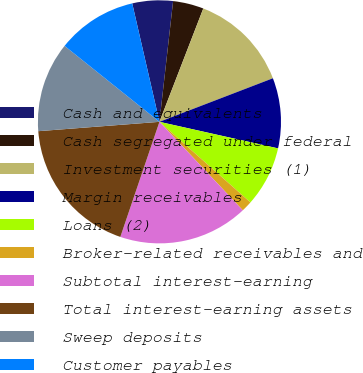Convert chart to OTSL. <chart><loc_0><loc_0><loc_500><loc_500><pie_chart><fcel>Cash and equivalents<fcel>Cash segregated under federal<fcel>Investment securities (1)<fcel>Margin receivables<fcel>Loans (2)<fcel>Broker-related receivables and<fcel>Subtotal interest-earning<fcel>Total interest-earning assets<fcel>Sweep deposits<fcel>Customer payables<nl><fcel>5.39%<fcel>4.08%<fcel>13.29%<fcel>9.34%<fcel>8.03%<fcel>1.44%<fcel>17.24%<fcel>18.56%<fcel>11.97%<fcel>10.66%<nl></chart> 